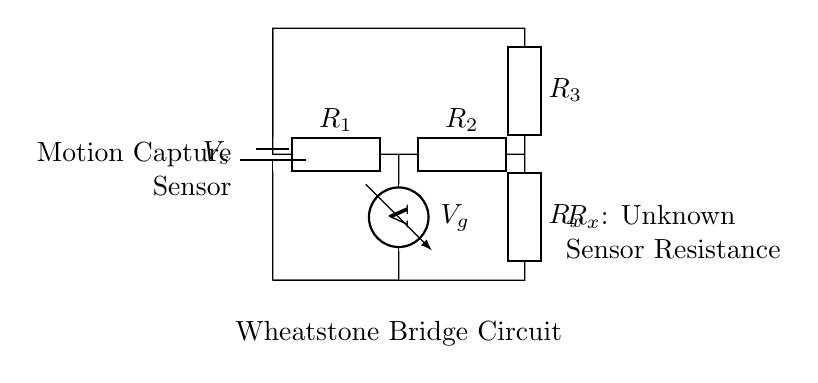What components are present in the circuit? The components are a voltage source, three resistors, and a voltmeter, as indicated in the schematic.
Answer: Voltage source, resistors, voltmeter What does R_x represent in the diagram? R_x represents the unknown resistance of the motion capture sensor, which is to be measured with the Wheatstone bridge.
Answer: Unknown sensor resistance What type of circuit is this? This is a Wheatstone bridge circuit, which is specifically designed for precise measurement of resistance.
Answer: Wheatstone bridge What is the role of the voltmeter in the circuit? The voltmeter measures the voltage difference between the two points of the bridge, which is essential for determining the balance of the circuit and calculating R_x.
Answer: Measure voltage difference How many resistors are in the circuit? There are three resistors in total, labeled R_1, R_2, and R_3, with R_x being the one to be measured.
Answer: Three resistors Which resistors are in the arms of the bridge? R_1 and R_2 form one arm of the bridge, while R_3 and R_x form the other arm; these arrangements maintain the balance of the circuit.
Answer: R_1, R_2 and R_3, R_x What does it mean if V_g equals zero volts? If V_g equals zero volts, it means the Wheatstone bridge is balanced, indicating that the ratio of R_1 to R_2 is equal to the ratio of R_3 to R_x, allowing for the exact measurement of R_x.
Answer: Balanced bridge 